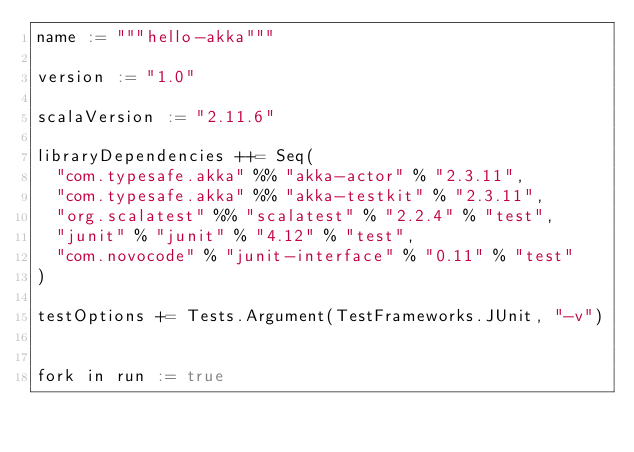Convert code to text. <code><loc_0><loc_0><loc_500><loc_500><_Scala_>name := """hello-akka"""

version := "1.0"

scalaVersion := "2.11.6"

libraryDependencies ++= Seq(
  "com.typesafe.akka" %% "akka-actor" % "2.3.11",
  "com.typesafe.akka" %% "akka-testkit" % "2.3.11",
  "org.scalatest" %% "scalatest" % "2.2.4" % "test",
  "junit" % "junit" % "4.12" % "test",
  "com.novocode" % "junit-interface" % "0.11" % "test"
)

testOptions += Tests.Argument(TestFrameworks.JUnit, "-v")


fork in run := true</code> 